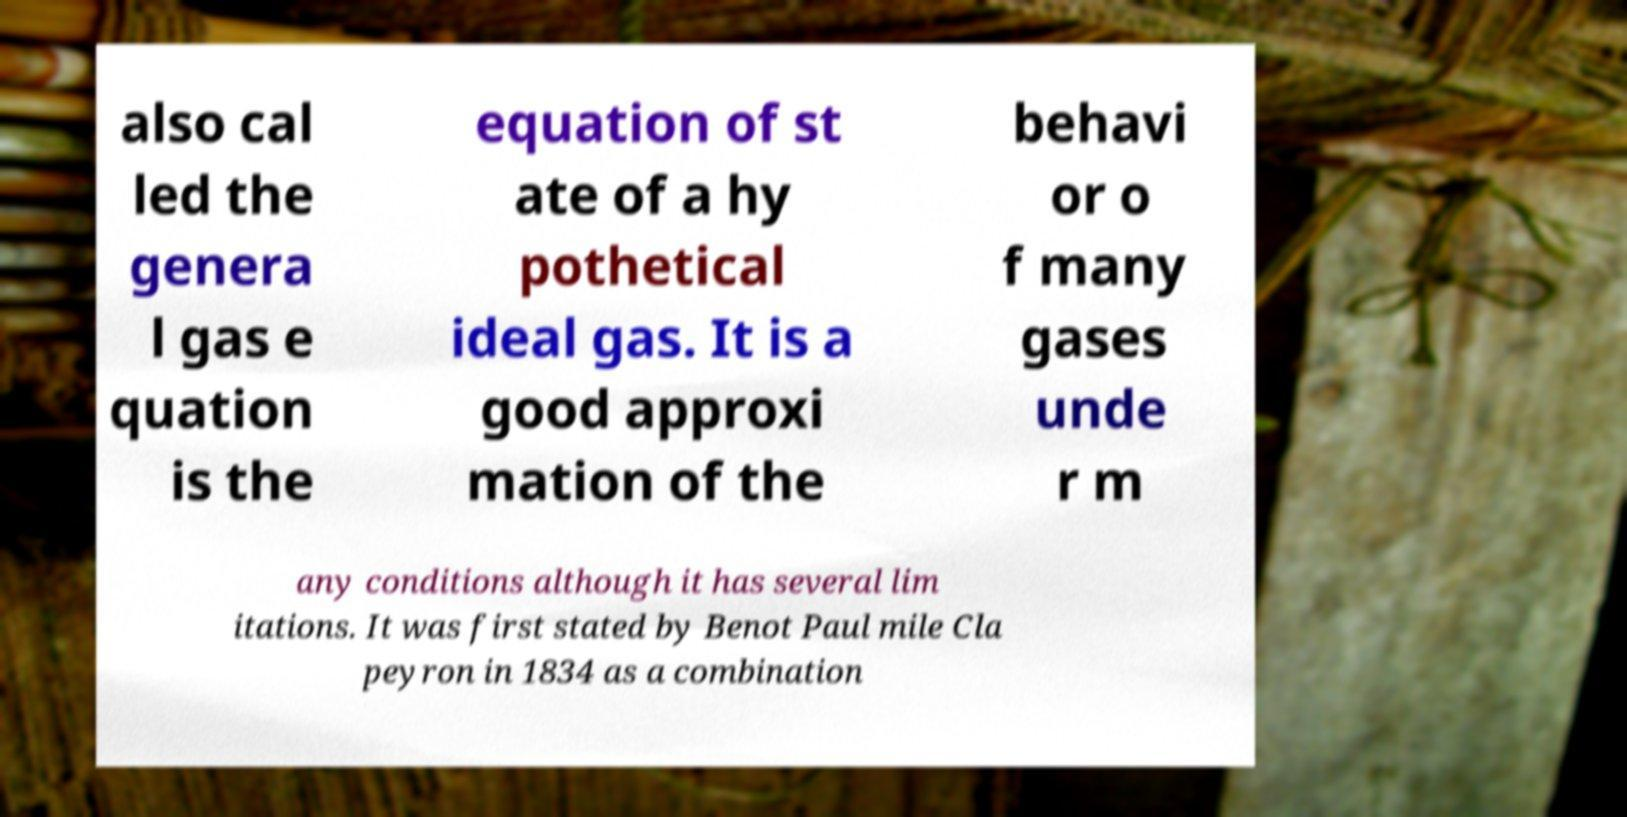There's text embedded in this image that I need extracted. Can you transcribe it verbatim? also cal led the genera l gas e quation is the equation of st ate of a hy pothetical ideal gas. It is a good approxi mation of the behavi or o f many gases unde r m any conditions although it has several lim itations. It was first stated by Benot Paul mile Cla peyron in 1834 as a combination 